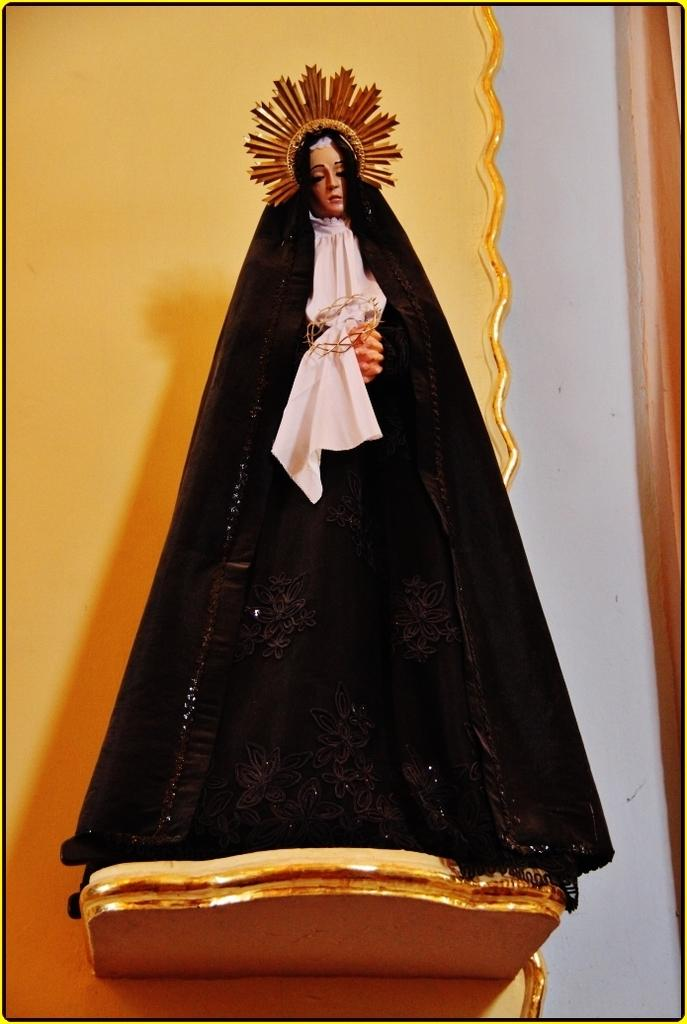What is the main subject of the image? The main subject of the image is a sculpture of a human being. What is the sculpture wearing? The sculpture has a black color dress. What is the sculpture wearing on its head? The sculpture has a brown color crown. What type of teeth can be seen on the sculpture in the image? There are no teeth visible on the sculpture in the image, as it is a sculpture and not a living being. 